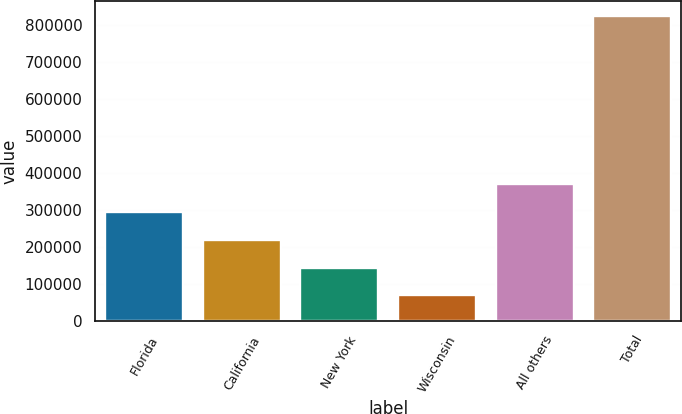Convert chart to OTSL. <chart><loc_0><loc_0><loc_500><loc_500><bar_chart><fcel>Florida<fcel>California<fcel>New York<fcel>Wisconsin<fcel>All others<fcel>Total<nl><fcel>294237<fcel>218866<fcel>143494<fcel>68123<fcel>369609<fcel>821837<nl></chart> 